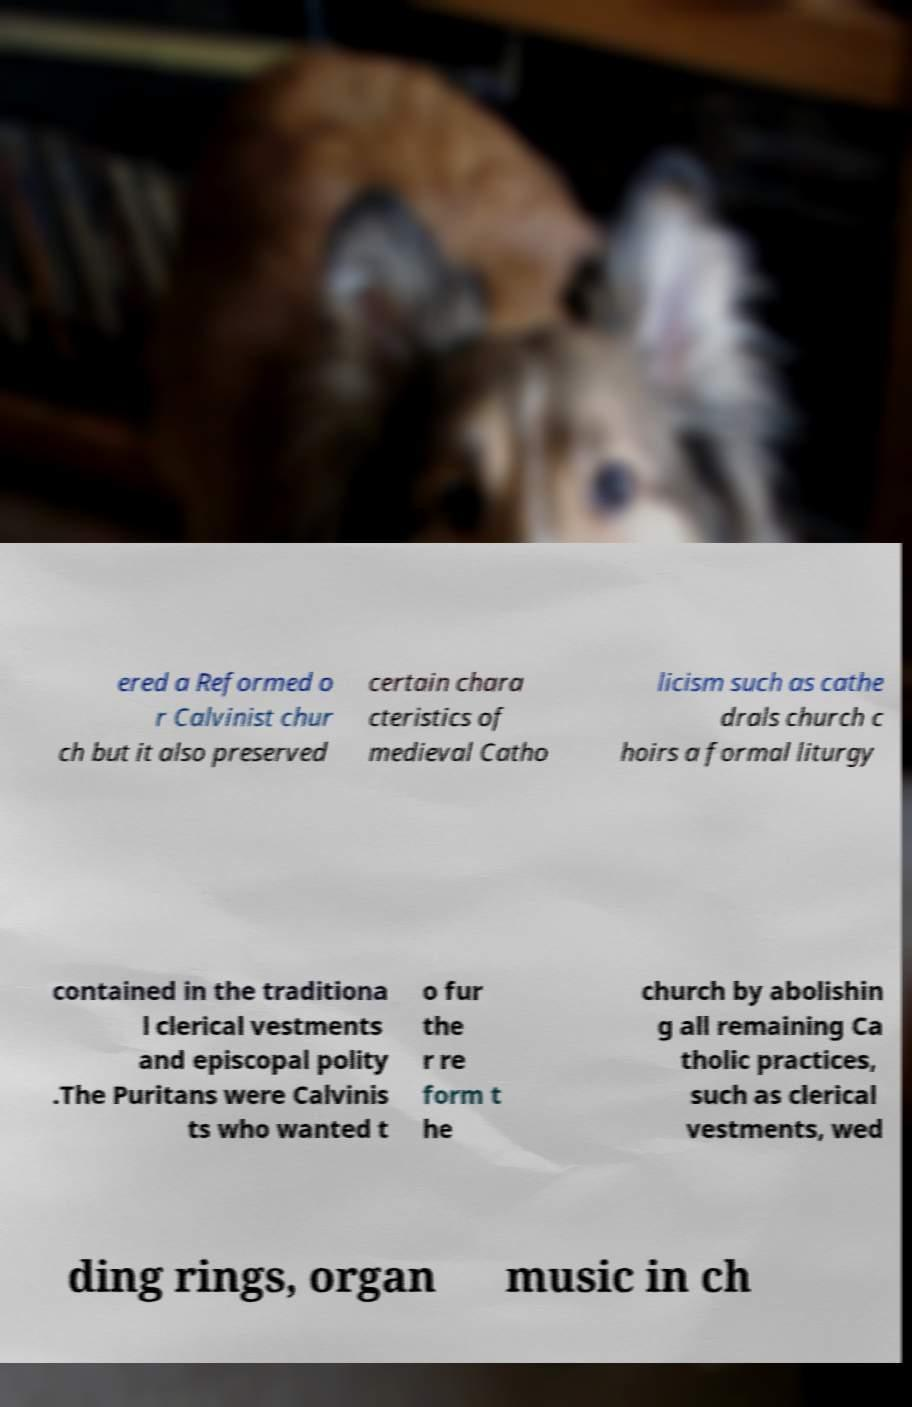For documentation purposes, I need the text within this image transcribed. Could you provide that? ered a Reformed o r Calvinist chur ch but it also preserved certain chara cteristics of medieval Catho licism such as cathe drals church c hoirs a formal liturgy contained in the traditiona l clerical vestments and episcopal polity .The Puritans were Calvinis ts who wanted t o fur the r re form t he church by abolishin g all remaining Ca tholic practices, such as clerical vestments, wed ding rings, organ music in ch 